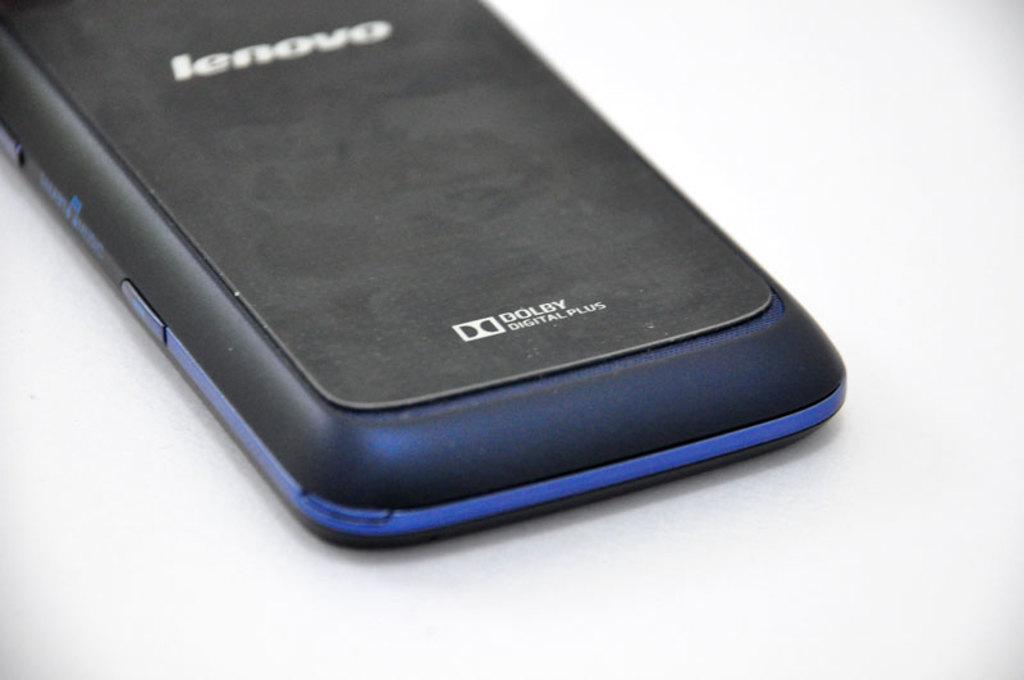Is that a lenovo phone?
Give a very brief answer. Yes. What is written below the dolby word on the phone?
Give a very brief answer. Digital plus. 